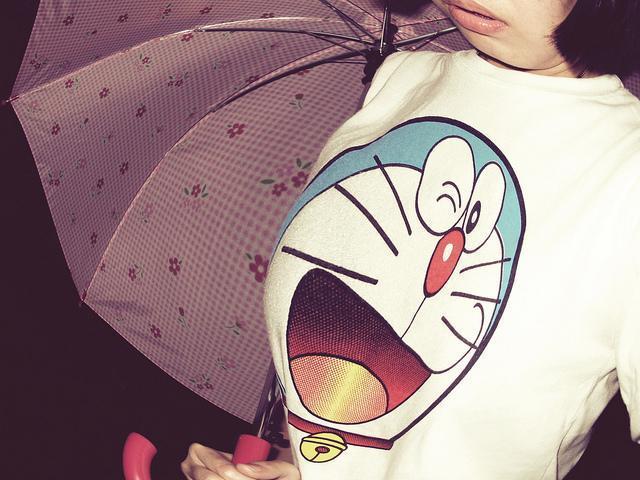How many people are there?
Give a very brief answer. 1. 